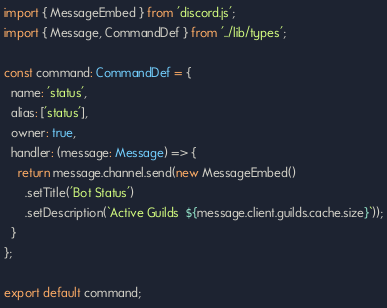<code> <loc_0><loc_0><loc_500><loc_500><_TypeScript_>import { MessageEmbed } from 'discord.js';
import { Message, CommandDef } from '../lib/types';

const command: CommandDef = {
  name: 'status',
  alias: ['status'],
  owner: true,
  handler: (message: Message) => {
    return message.channel.send(new MessageEmbed()
      .setTitle('Bot Status')
      .setDescription(`Active Guilds  ${message.client.guilds.cache.size}`));
  }
};

export default command;
</code> 